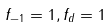Convert formula to latex. <formula><loc_0><loc_0><loc_500><loc_500>f _ { - 1 } = 1 , f _ { d } = 1</formula> 